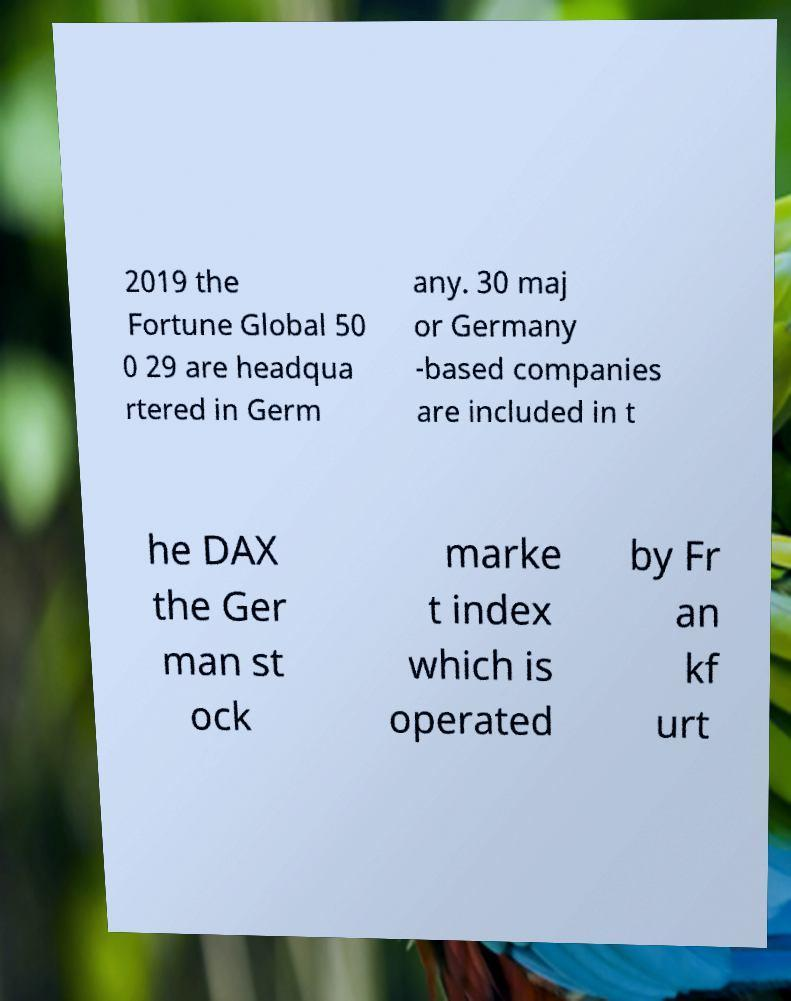Please identify and transcribe the text found in this image. 2019 the Fortune Global 50 0 29 are headqua rtered in Germ any. 30 maj or Germany -based companies are included in t he DAX the Ger man st ock marke t index which is operated by Fr an kf urt 